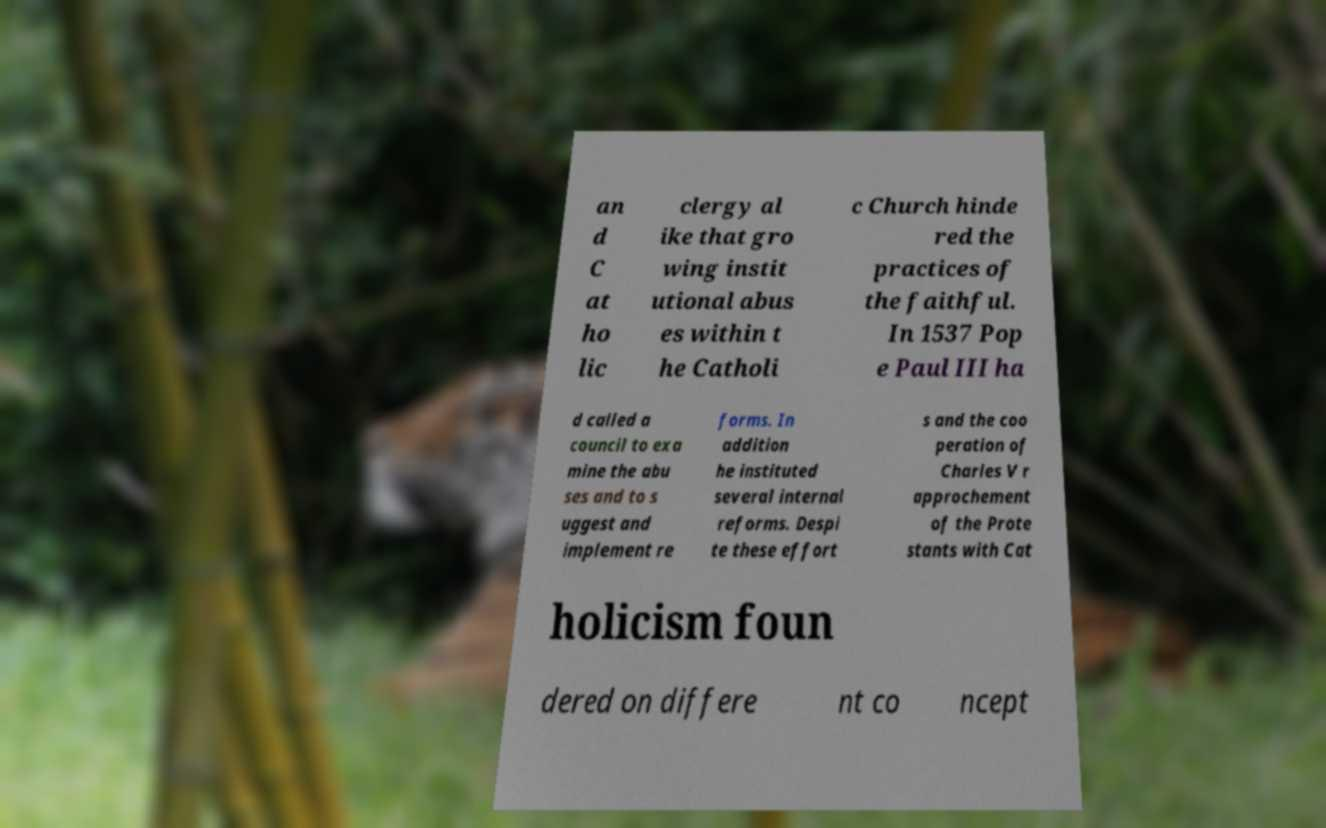I need the written content from this picture converted into text. Can you do that? an d C at ho lic clergy al ike that gro wing instit utional abus es within t he Catholi c Church hinde red the practices of the faithful. In 1537 Pop e Paul III ha d called a council to exa mine the abu ses and to s uggest and implement re forms. In addition he instituted several internal reforms. Despi te these effort s and the coo peration of Charles V r approchement of the Prote stants with Cat holicism foun dered on differe nt co ncept 